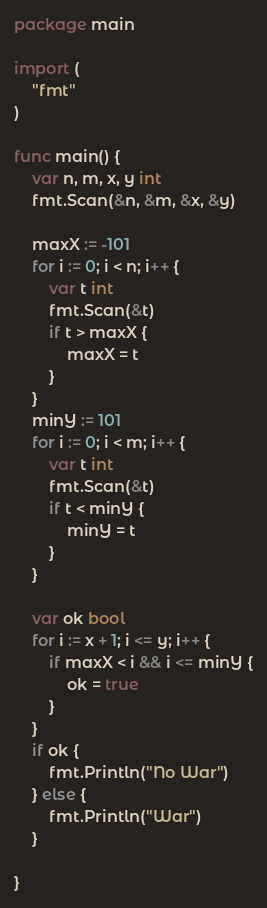Convert code to text. <code><loc_0><loc_0><loc_500><loc_500><_Go_>package main

import (
    "fmt"
)

func main() {
    var n, m, x, y int
    fmt.Scan(&n, &m, &x, &y)

    maxX := -101
    for i := 0; i < n; i++ {
        var t int
        fmt.Scan(&t)
        if t > maxX {
            maxX = t
        }
    }
    minY := 101
    for i := 0; i < m; i++ {
        var t int
        fmt.Scan(&t)
        if t < minY {
            minY = t
        }
    }

    var ok bool
    for i := x + 1; i <= y; i++ {
        if maxX < i && i <= minY {
            ok = true
        }
    }
    if ok {
        fmt.Println("No War")
    } else {
        fmt.Println("War")
    }

}
</code> 